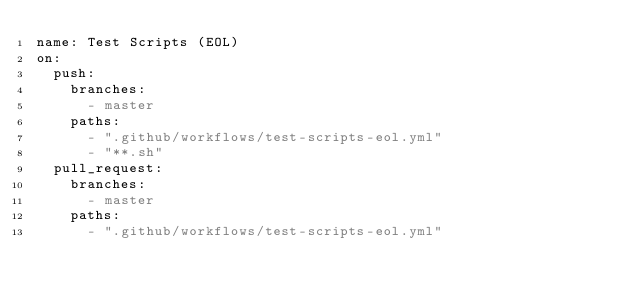Convert code to text. <code><loc_0><loc_0><loc_500><loc_500><_YAML_>name: Test Scripts (EOL)
on:
  push:
    branches:
      - master
    paths:
      - ".github/workflows/test-scripts-eol.yml"
      - "**.sh"
  pull_request:
    branches:
      - master
    paths:
      - ".github/workflows/test-scripts-eol.yml"</code> 